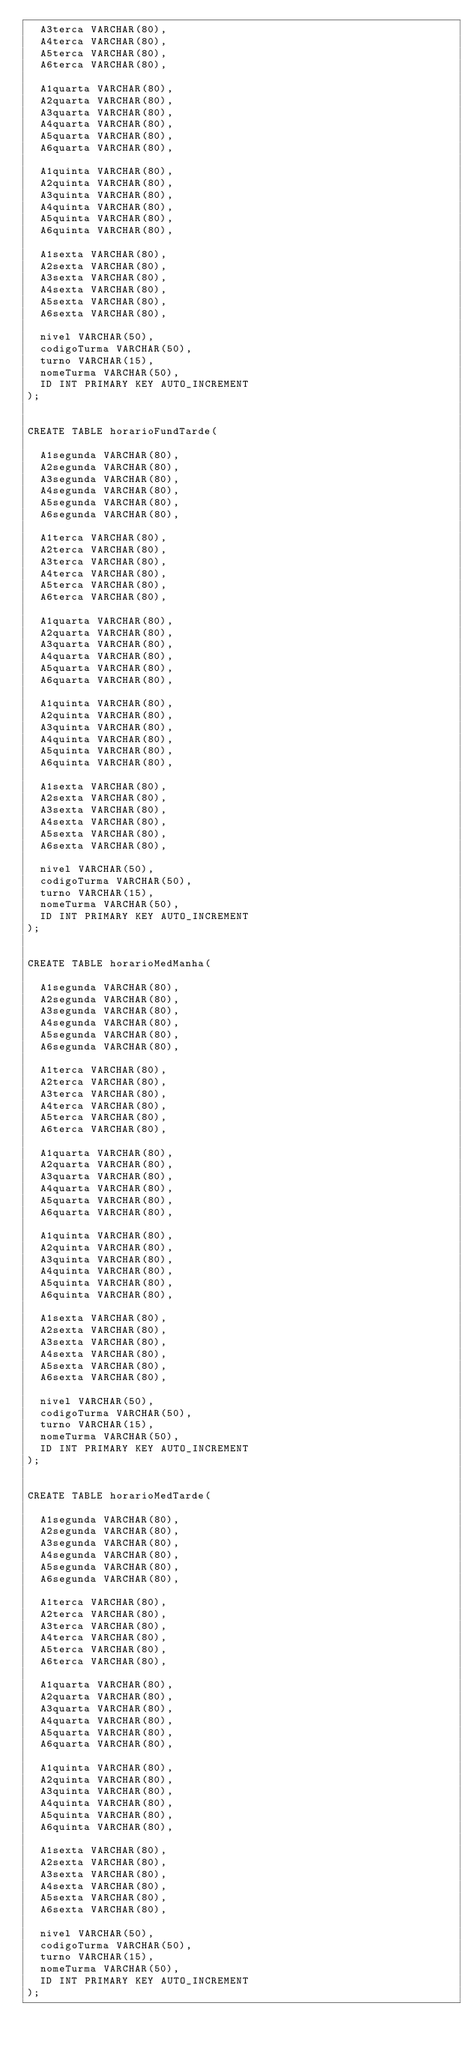<code> <loc_0><loc_0><loc_500><loc_500><_SQL_>	A3terca VARCHAR(80),
	A4terca VARCHAR(80),
	A5terca VARCHAR(80),
	A6terca VARCHAR(80),

	A1quarta VARCHAR(80),
	A2quarta VARCHAR(80),
	A3quarta VARCHAR(80),
	A4quarta VARCHAR(80),
	A5quarta VARCHAR(80),
	A6quarta VARCHAR(80),

	A1quinta VARCHAR(80),
	A2quinta VARCHAR(80),
	A3quinta VARCHAR(80),
	A4quinta VARCHAR(80),
	A5quinta VARCHAR(80),
	A6quinta VARCHAR(80),

	A1sexta VARCHAR(80),
	A2sexta VARCHAR(80),
	A3sexta VARCHAR(80),
	A4sexta VARCHAR(80),
	A5sexta VARCHAR(80),
	A6sexta VARCHAR(80),

	nivel VARCHAR(50),
	codigoTurma VARCHAR(50),
	turno VARCHAR(15),
	nomeTurma VARCHAR(50),
	ID INT PRIMARY KEY AUTO_INCREMENT
);


CREATE TABLE horarioFundTarde(

	A1segunda VARCHAR(80),
	A2segunda VARCHAR(80),
	A3segunda VARCHAR(80),
	A4segunda VARCHAR(80),
	A5segunda VARCHAR(80),
	A6segunda VARCHAR(80),

	A1terca VARCHAR(80),
	A2terca VARCHAR(80),
	A3terca VARCHAR(80),
	A4terca VARCHAR(80),
	A5terca VARCHAR(80),
	A6terca VARCHAR(80),

	A1quarta VARCHAR(80),
	A2quarta VARCHAR(80),
	A3quarta VARCHAR(80),
	A4quarta VARCHAR(80),
	A5quarta VARCHAR(80),
	A6quarta VARCHAR(80),

	A1quinta VARCHAR(80),
	A2quinta VARCHAR(80),
	A3quinta VARCHAR(80),
	A4quinta VARCHAR(80),
	A5quinta VARCHAR(80),
	A6quinta VARCHAR(80),

	A1sexta VARCHAR(80),
	A2sexta VARCHAR(80),
	A3sexta VARCHAR(80),
	A4sexta VARCHAR(80),
	A5sexta VARCHAR(80),
	A6sexta VARCHAR(80),

	nivel VARCHAR(50),
	codigoTurma VARCHAR(50),
	turno VARCHAR(15),
	nomeTurma VARCHAR(50),
	ID INT PRIMARY KEY AUTO_INCREMENT
);


CREATE TABLE horarioMedManha(

	A1segunda VARCHAR(80),
	A2segunda VARCHAR(80),
	A3segunda VARCHAR(80),
	A4segunda VARCHAR(80),
	A5segunda VARCHAR(80),
	A6segunda VARCHAR(80),

	A1terca VARCHAR(80),
	A2terca VARCHAR(80),
	A3terca VARCHAR(80),
	A4terca VARCHAR(80),
	A5terca VARCHAR(80),
	A6terca VARCHAR(80),

	A1quarta VARCHAR(80),
	A2quarta VARCHAR(80),
	A3quarta VARCHAR(80),
	A4quarta VARCHAR(80),
	A5quarta VARCHAR(80),
	A6quarta VARCHAR(80),

	A1quinta VARCHAR(80),
	A2quinta VARCHAR(80),
	A3quinta VARCHAR(80),
	A4quinta VARCHAR(80),
	A5quinta VARCHAR(80),
	A6quinta VARCHAR(80),

	A1sexta VARCHAR(80),
	A2sexta VARCHAR(80),
	A3sexta VARCHAR(80),
	A4sexta VARCHAR(80),
	A5sexta VARCHAR(80),
	A6sexta VARCHAR(80),

	nivel VARCHAR(50),
	codigoTurma VARCHAR(50),
	turno VARCHAR(15),
	nomeTurma VARCHAR(50),
	ID INT PRIMARY KEY AUTO_INCREMENT
);


CREATE TABLE horarioMedTarde(

	A1segunda VARCHAR(80),
	A2segunda VARCHAR(80),
	A3segunda VARCHAR(80),
	A4segunda VARCHAR(80),
	A5segunda VARCHAR(80),
	A6segunda VARCHAR(80),

	A1terca VARCHAR(80),
	A2terca VARCHAR(80),
	A3terca VARCHAR(80),
	A4terca VARCHAR(80),
	A5terca VARCHAR(80),
	A6terca VARCHAR(80),

	A1quarta VARCHAR(80),
	A2quarta VARCHAR(80),
	A3quarta VARCHAR(80),
	A4quarta VARCHAR(80),
	A5quarta VARCHAR(80),
	A6quarta VARCHAR(80),

	A1quinta VARCHAR(80),
	A2quinta VARCHAR(80),
	A3quinta VARCHAR(80),
	A4quinta VARCHAR(80),
	A5quinta VARCHAR(80),
	A6quinta VARCHAR(80),

	A1sexta VARCHAR(80),
	A2sexta VARCHAR(80),
	A3sexta VARCHAR(80),
	A4sexta VARCHAR(80),
	A5sexta VARCHAR(80),
	A6sexta VARCHAR(80),

	nivel VARCHAR(50),
	codigoTurma VARCHAR(50),
	turno VARCHAR(15),
	nomeTurma VARCHAR(50),
	ID INT PRIMARY KEY AUTO_INCREMENT
);
</code> 